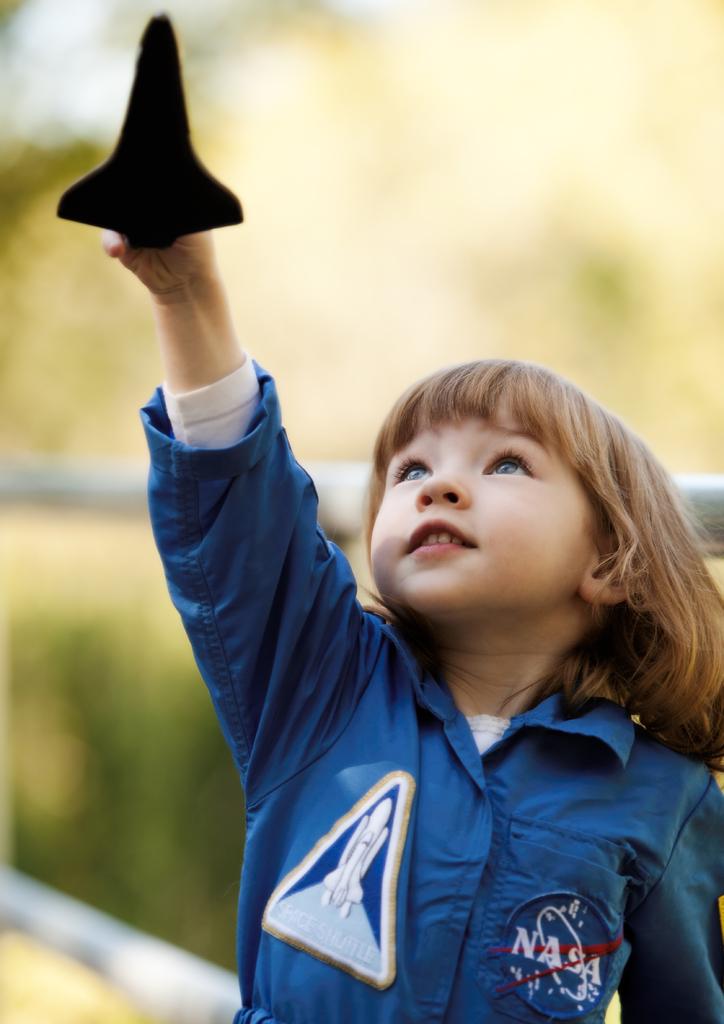What does the patch on the left say beneath the picture of the rocket?
Your answer should be compact. Space shuttle. 